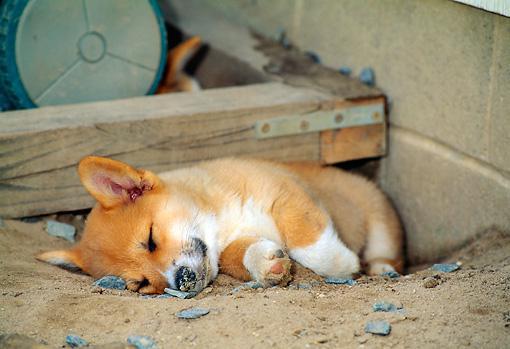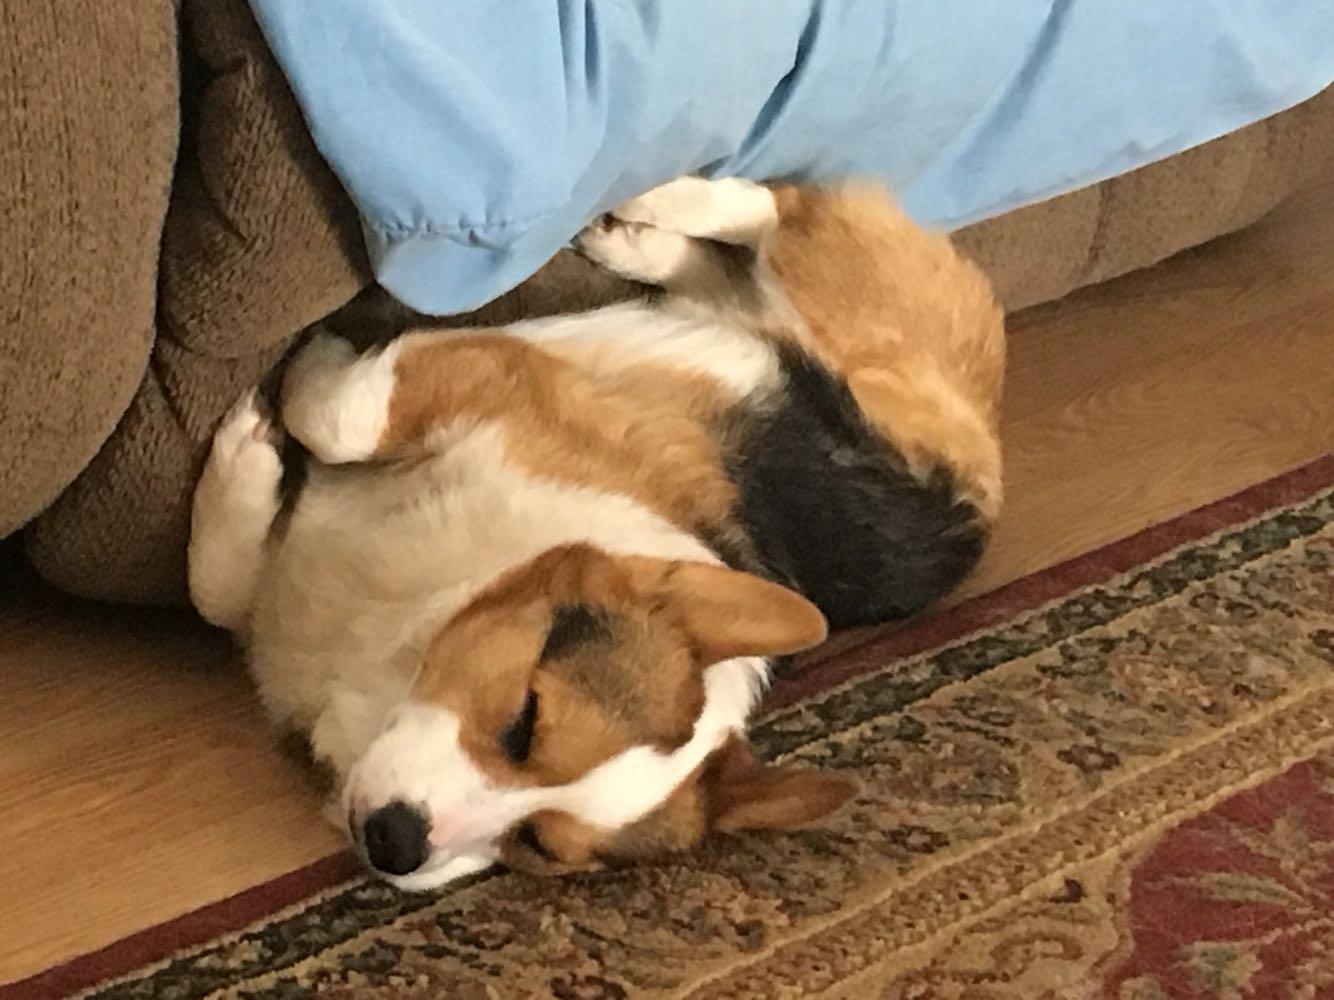The first image is the image on the left, the second image is the image on the right. Considering the images on both sides, is "There is at most 1 young Corgi laying on it right side, sleeping." valid? Answer yes or no. Yes. 